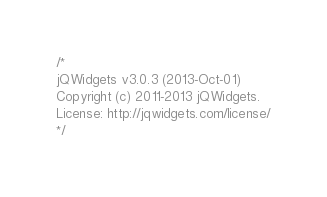<code> <loc_0><loc_0><loc_500><loc_500><_JavaScript_>/*
jQWidgets v3.0.3 (2013-Oct-01)
Copyright (c) 2011-2013 jQWidgets.
License: http://jqwidgets.com/license/
*/
</code> 